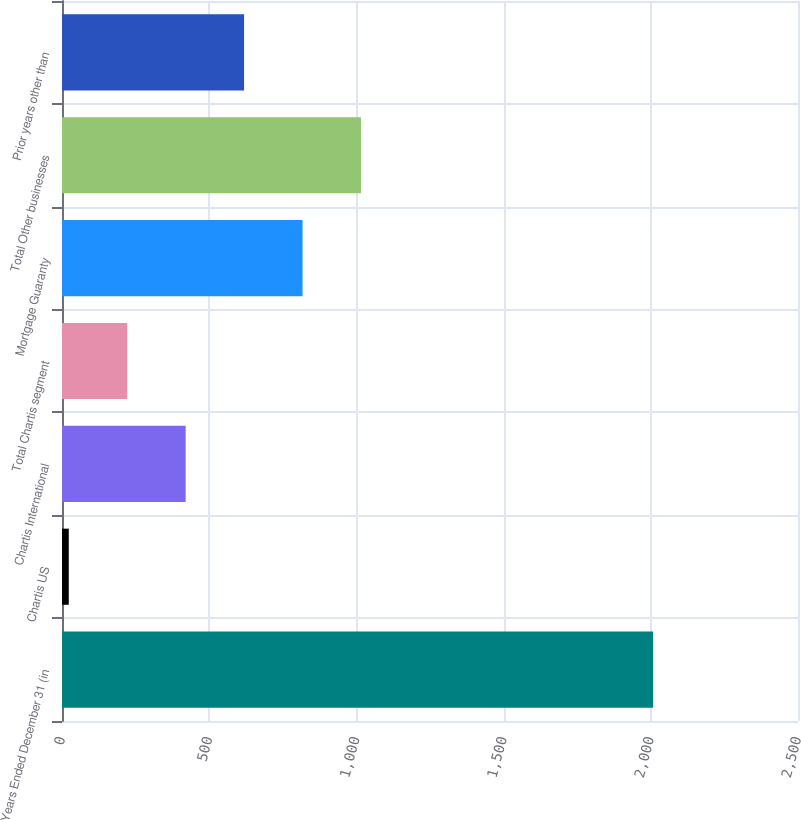Convert chart to OTSL. <chart><loc_0><loc_0><loc_500><loc_500><bar_chart><fcel>Years Ended December 31 (in<fcel>Chartis US<fcel>Chartis International<fcel>Total Chartis segment<fcel>Mortgage Guaranty<fcel>Total Other businesses<fcel>Prior years other than<nl><fcel>2008<fcel>23<fcel>420<fcel>221.5<fcel>817<fcel>1015.5<fcel>618.5<nl></chart> 